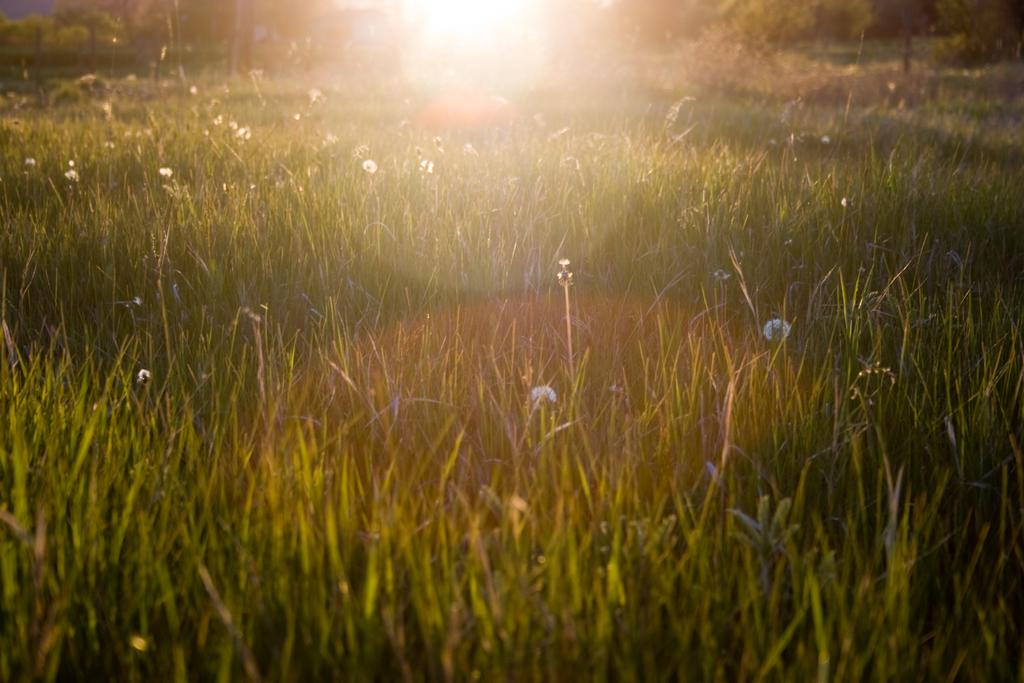What type of living organisms can be seen in the image? Plants and flowers are visible in the image. What is the color of the plants in the image? The plants are green in color. What can be seen in the background of the image? Trees and the sun are visible in the background of the image. Where is the market located in the image? There is no market present in the image. What type of net is being used to catch the grain in the image? There is no net or grain present in the image. 